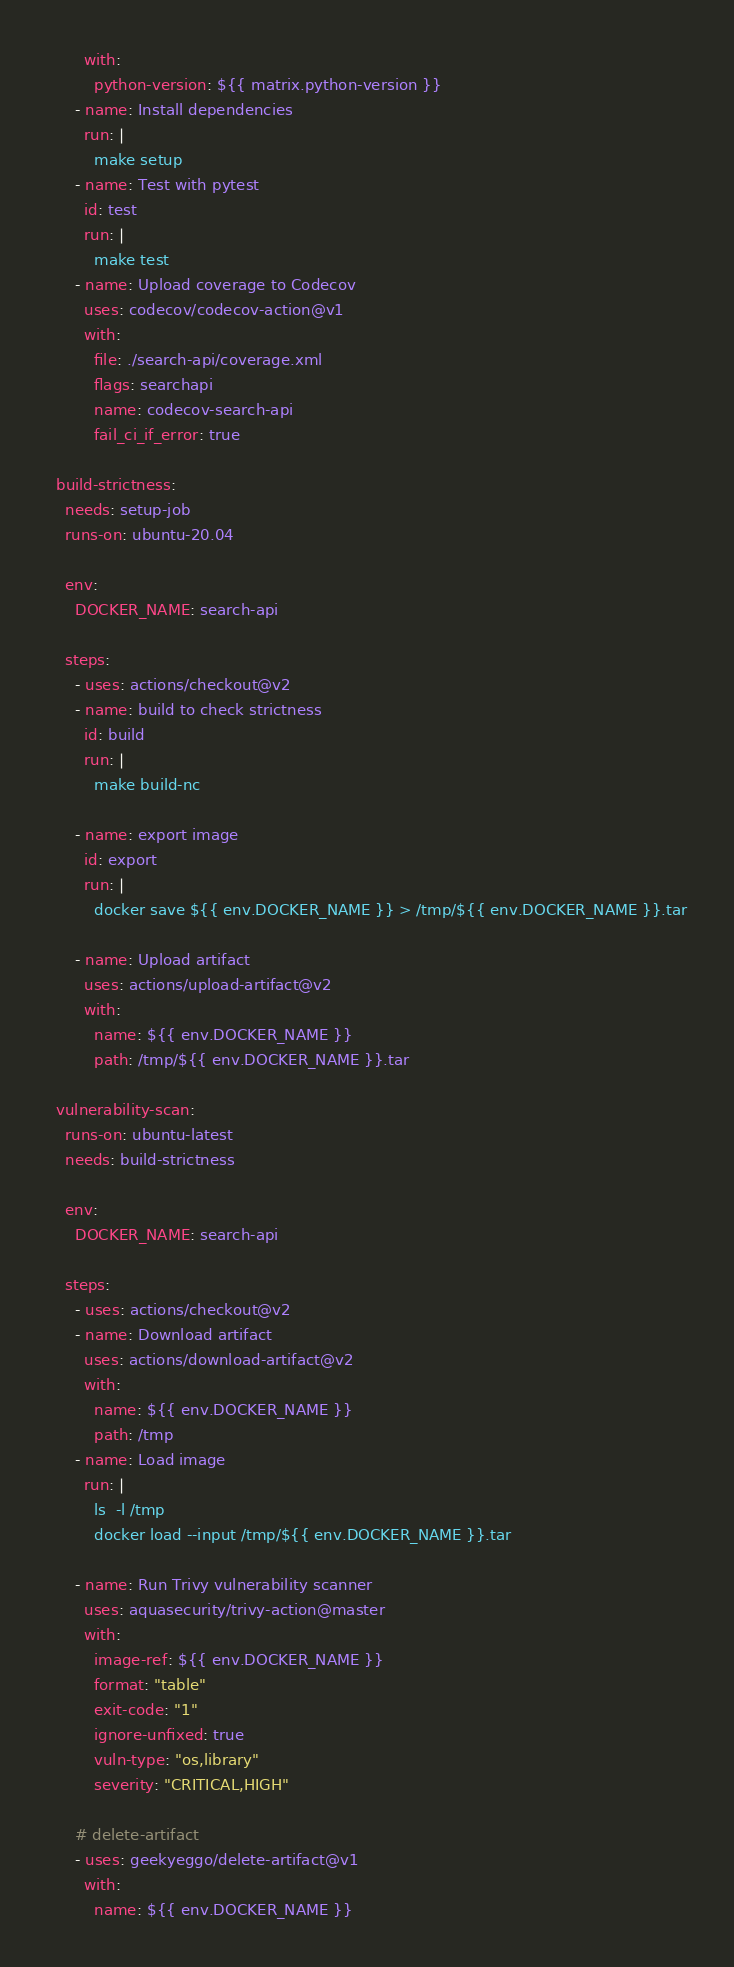<code> <loc_0><loc_0><loc_500><loc_500><_YAML_>        with:
          python-version: ${{ matrix.python-version }}
      - name: Install dependencies
        run: |
          make setup
      - name: Test with pytest
        id: test
        run: |
          make test
      - name: Upload coverage to Codecov
        uses: codecov/codecov-action@v1
        with:
          file: ./search-api/coverage.xml
          flags: searchapi
          name: codecov-search-api
          fail_ci_if_error: true

  build-strictness:
    needs: setup-job
    runs-on: ubuntu-20.04

    env:
      DOCKER_NAME: search-api

    steps:
      - uses: actions/checkout@v2
      - name: build to check strictness
        id: build
        run: |
          make build-nc

      - name: export image
        id: export
        run: |
          docker save ${{ env.DOCKER_NAME }} > /tmp/${{ env.DOCKER_NAME }}.tar

      - name: Upload artifact
        uses: actions/upload-artifact@v2
        with:
          name: ${{ env.DOCKER_NAME }}
          path: /tmp/${{ env.DOCKER_NAME }}.tar

  vulnerability-scan:
    runs-on: ubuntu-latest
    needs: build-strictness

    env:
      DOCKER_NAME: search-api

    steps:
      - uses: actions/checkout@v2
      - name: Download artifact
        uses: actions/download-artifact@v2
        with:
          name: ${{ env.DOCKER_NAME }}
          path: /tmp
      - name: Load image
        run: |
          ls  -l /tmp
          docker load --input /tmp/${{ env.DOCKER_NAME }}.tar

      - name: Run Trivy vulnerability scanner
        uses: aquasecurity/trivy-action@master
        with:
          image-ref: ${{ env.DOCKER_NAME }}
          format: "table"
          exit-code: "1"
          ignore-unfixed: true
          vuln-type: "os,library"
          severity: "CRITICAL,HIGH"

      # delete-artifact
      - uses: geekyeggo/delete-artifact@v1
        with:
          name: ${{ env.DOCKER_NAME }}
</code> 